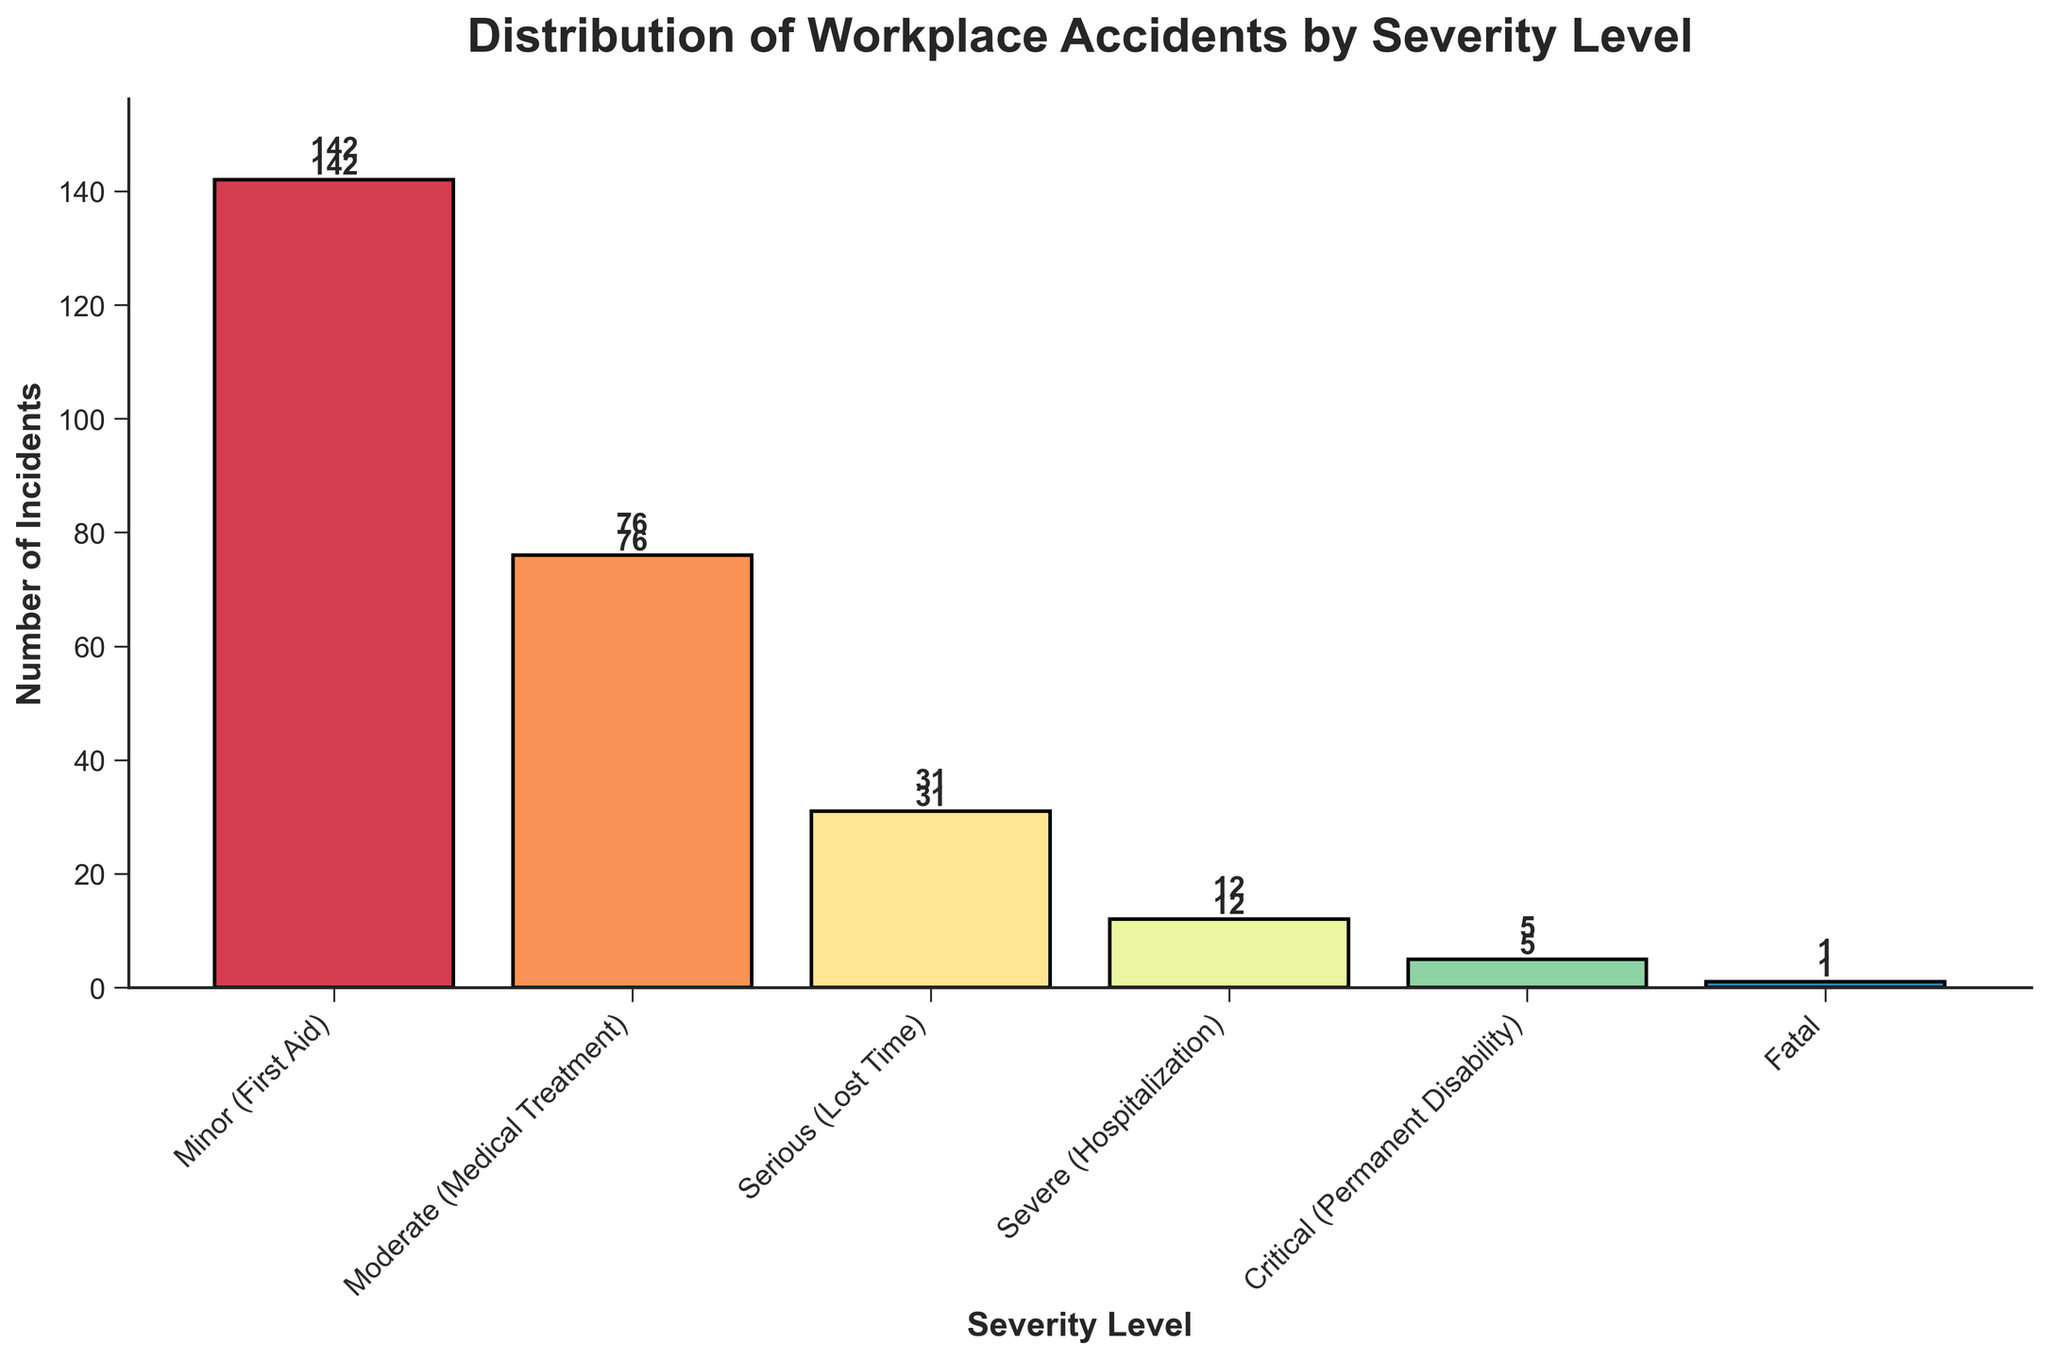What is the title of the figure? The title is usually located at the top of the figure. For this plot, the title is "Distribution of Workplace Accidents by Severity Level".
Answer: Distribution of Workplace Accidents by Severity Level How many workplace incidents were classified as minor (First Aid)? Look for the bar corresponding to "Minor (First Aid)" and check the height, as well as the label on top of the bar. The bar indicates 142 incidents.
Answer: 142 Which severity level has the fewest number of incidents? Identify the bar with the smallest height in the chart. The bar labeled "Fatal" is the shortest, indicating only 1 incident.
Answer: Fatal How many more minor incidents are there compared to severe incidents? Calculate the number between minor (142) and severe (12) incidents. The difference is 142 - 12.
Answer: 130 What is the total number of incidents across all severity levels? Add the numbers of each severity level: 142 + 76 + 31 + 12 + 5 + 1.
Answer: 267 How many incidents required hospitalization or resulted in a more severe outcome? Sum the incidents classified as "Severe (Hospitalization)" and more severe categories: 12 + 5 + 1.
Answer: 18 What is the ratio of minor incidents to serious incidents? Find the ratio between the number of minor incidents (142) and serious incidents (31): 142/31.
Answer: 4.58 Which severity level has nearly half the number of incidents as moderate (Medical Treatment)? Compare the incidents for each severity level with half of the moderate level's incidents (76/2 = 38). The "Serious (Lost Time)" level has 31 incidents which is slightly less than half, while "Minor (First Aid)" has 142 and is not close, and others are much lower.
Answer: Serious (Lost Time) How does the number of fatal incidents compare to the number of minor incidents? Directly compare the number of fatal incidents (1) to minor incidents (142). Fatal incidents are significantly fewer than minor incidents.
Answer: Much fewer 